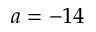<formula> <loc_0><loc_0><loc_500><loc_500>a = - 1 4</formula> 